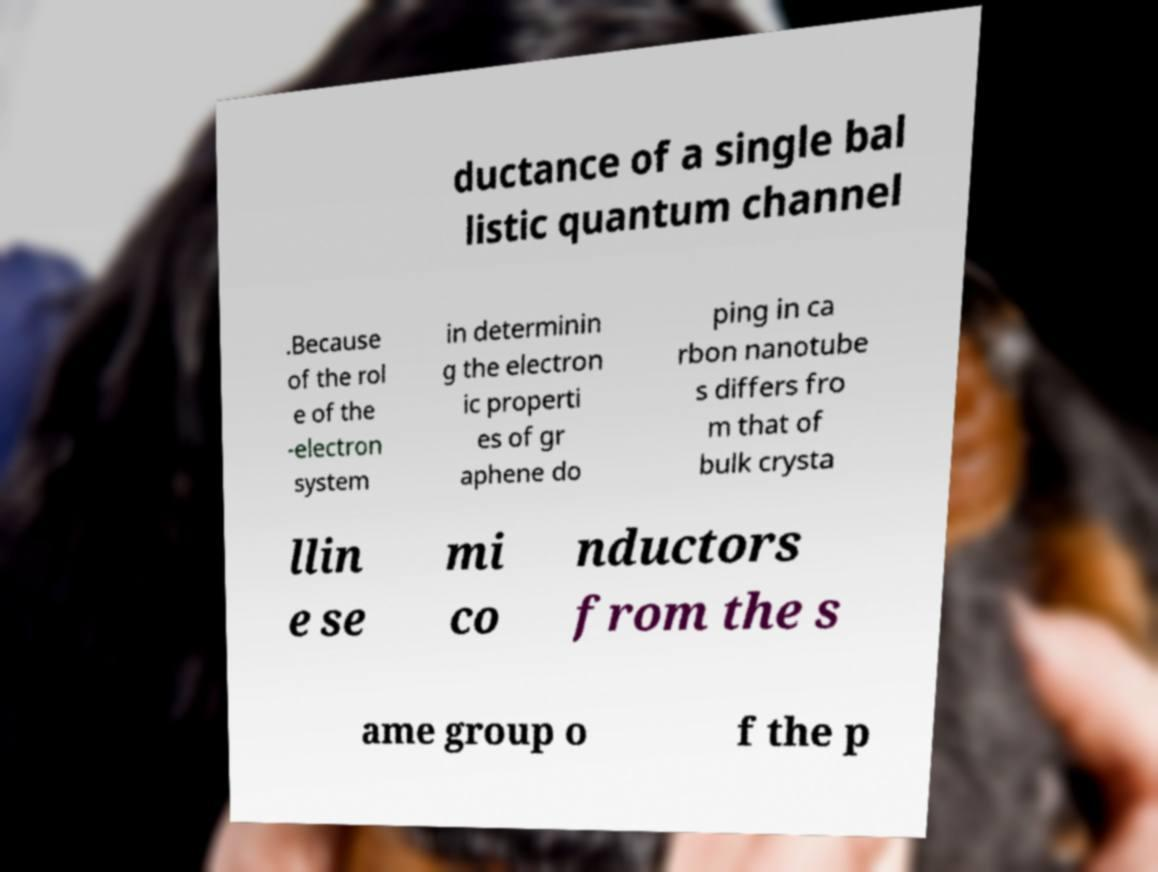Could you extract and type out the text from this image? ductance of a single bal listic quantum channel .Because of the rol e of the -electron system in determinin g the electron ic properti es of gr aphene do ping in ca rbon nanotube s differs fro m that of bulk crysta llin e se mi co nductors from the s ame group o f the p 